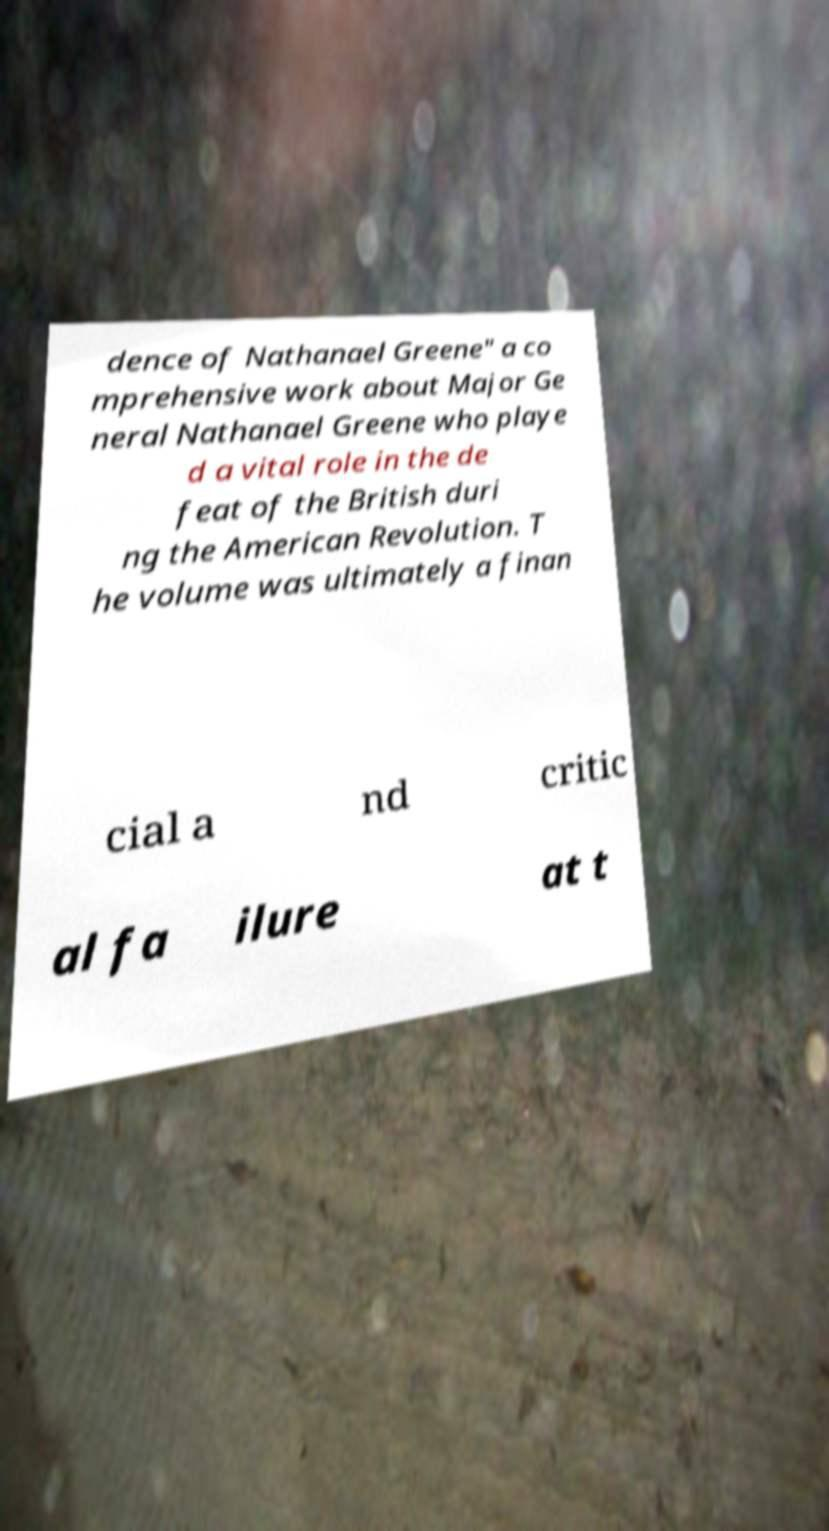Can you read and provide the text displayed in the image?This photo seems to have some interesting text. Can you extract and type it out for me? dence of Nathanael Greene" a co mprehensive work about Major Ge neral Nathanael Greene who playe d a vital role in the de feat of the British duri ng the American Revolution. T he volume was ultimately a finan cial a nd critic al fa ilure at t 